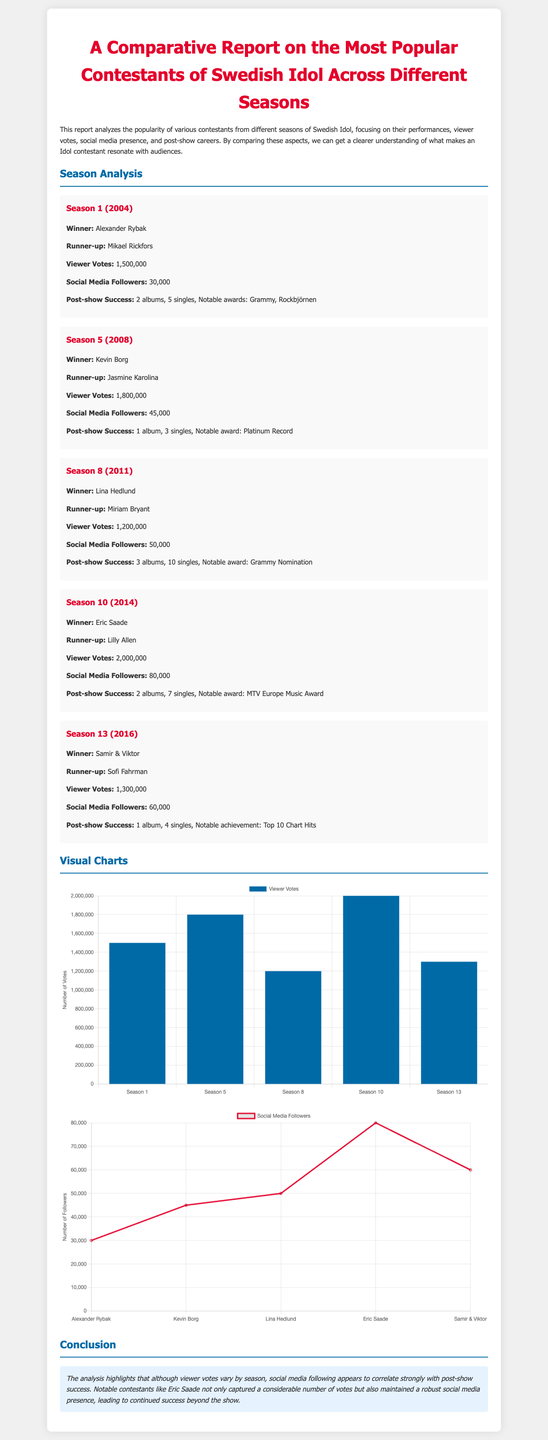What is the winner of Season 1? The winner of Season 1 is Alexander Rybak, as stated in the season analysis section.
Answer: Alexander Rybak How many viewer votes did Season 10 receive? The document states that Season 10 received 2,000,000 viewer votes, found in the season analysis section.
Answer: 2,000,000 Who was the runner-up in Season 5? The runner-up of Season 5 is Jasmine Karolina, specified in the season 5 analysis.
Answer: Jasmine Karolina What is the notable award received by Lina Hedlund? The document notes that Lina Hedlund received a Grammy nomination as her notable award.
Answer: Grammy Nomination Which contestant has the highest number of social media followers? Eric Saade has the highest number of social media followers among the listed contestants in the report, with 80,000 followers.
Answer: 80,000 Which season had the lowest viewer votes? Season 8 recorded the lowest viewer votes at 1,200,000, as seen in the viewer votes chart.
Answer: 1,200,000 What correlation is highlighted in the document about social media following? The report suggests a correlation between social media following and post-show success.
Answer: Correlation What type of chart is used to display viewer votes? The viewer votes are displayed using a bar chart, as mentioned in the visual charts section.
Answer: Bar chart How many albums did Kevin Borg release after his win? Kevin Borg released 1 album after his win, detailed in the season 5 analysis.
Answer: 1 album 